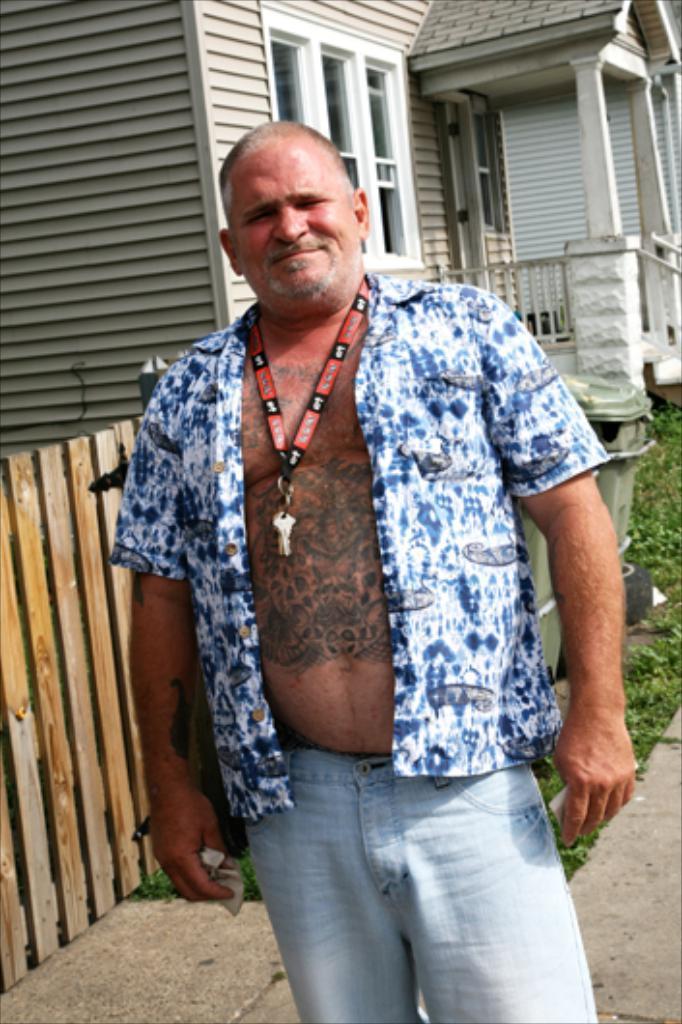How would you summarize this image in a sentence or two? In the picture i can see a person wearing blue color shirt, pant standing and in the background there is a house, there are some plants. 